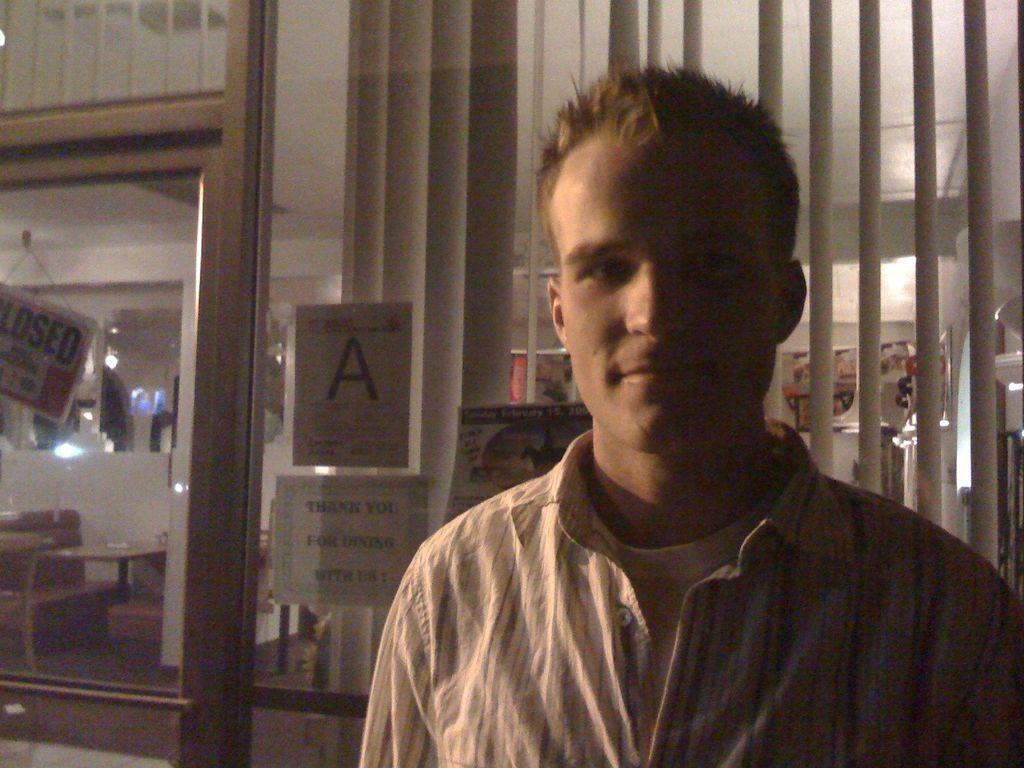Describe this image in one or two sentences. In the center of the image there is a person. In the background there is a glass window and curtain. 